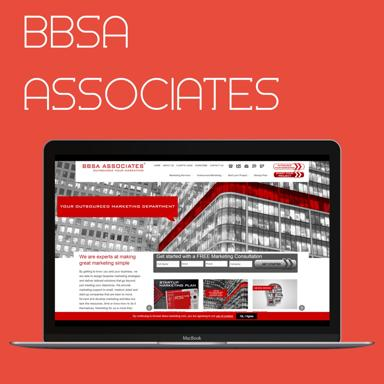What type of business does BBSA Associates appear to be involved in based on the website content visible in the image? BBSA Associates appears to be a marketing consultancy firm. The laptop screen shows phrases such as 'value-structured marketing department' and 'global marketing campaigns', suggesting a focus on providing strategic marketing solutions to clients. 